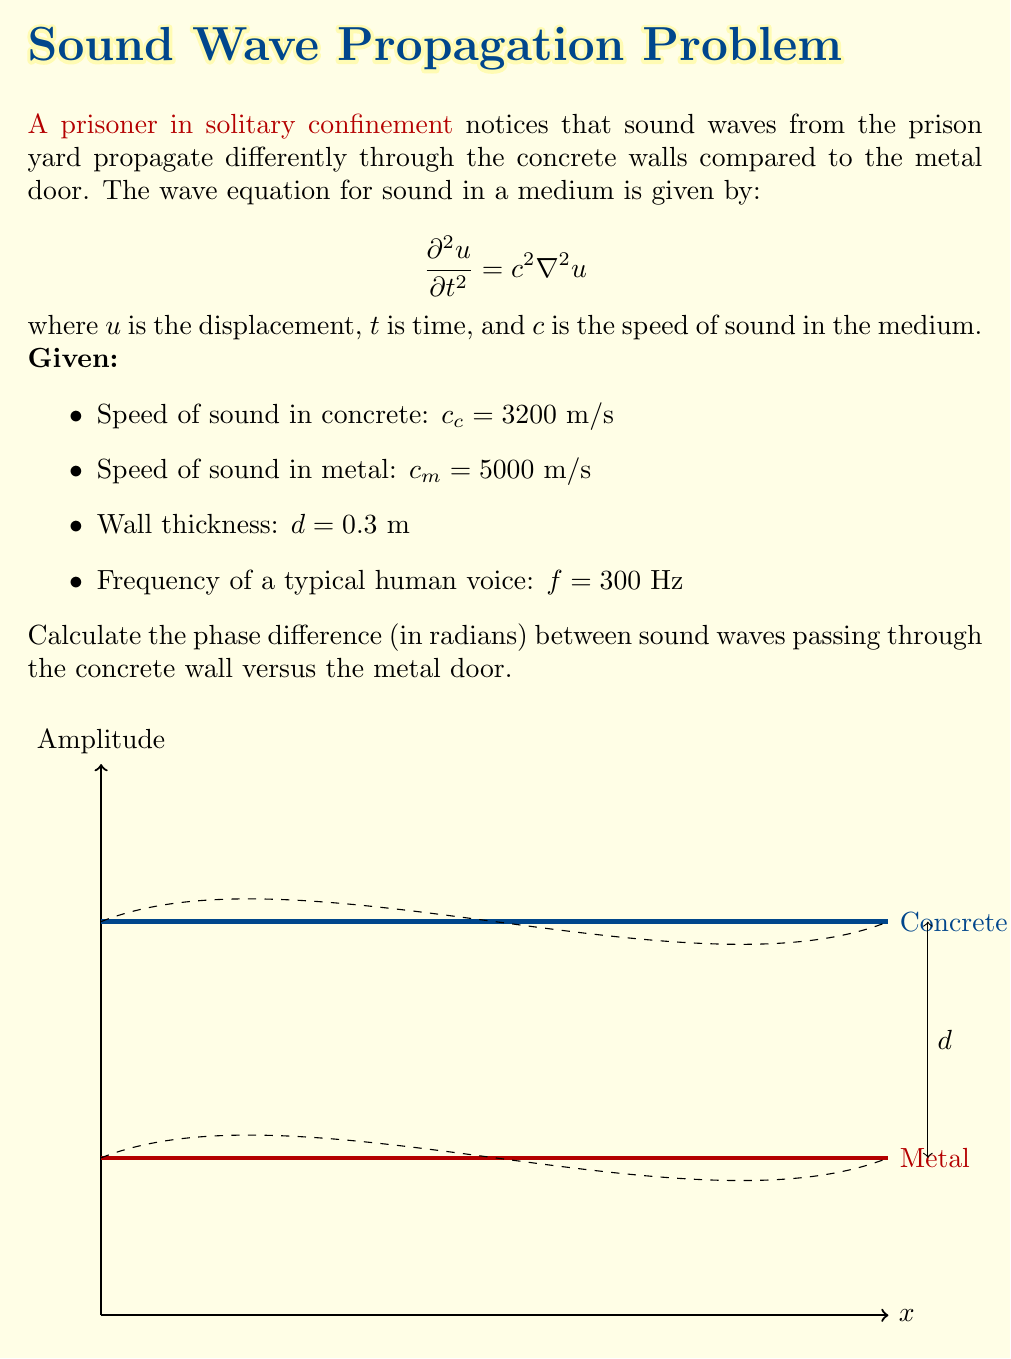What is the answer to this math problem? To solve this problem, we'll follow these steps:

1) First, we need to calculate the wavenumber $k$ for each medium:
   $$k = \frac{2\pi f}{c}$$

   For concrete: $k_c = \frac{2\pi \cdot 300}{3200} = 0.5890$ rad/m
   For metal: $k_m = \frac{2\pi \cdot 300}{5000} = 0.3770$ rad/m

2) The phase change as the wave passes through a medium of thickness $d$ is given by $kd$.

   For concrete: $\phi_c = k_c d = 0.5890 \cdot 0.3 = 0.1767$ rad
   For metal: $\phi_m = k_m d = 0.3770 \cdot 0.3 = 0.1131$ rad

3) The phase difference is the absolute difference between these two phases:

   $$\Delta \phi = |\phi_c - \phi_m| = |0.1767 - 0.1131| = 0.0636$$ rad

This phase difference represents how much the waves passing through concrete are out of phase with those passing through metal, which affects how the prisoner perceives sounds from outside.
Answer: 0.0636 rad 